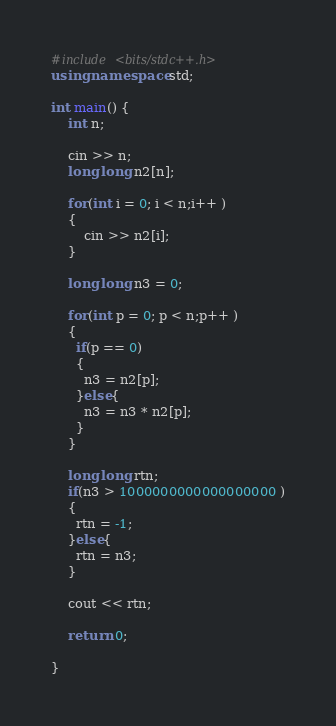<code> <loc_0><loc_0><loc_500><loc_500><_C++_>#include <bits/stdc++.h>
using namespace std;
 
int main() {
    int n;
    
    cin >> n;
    long long n2[n]; 
    
    for(int i = 0; i < n;i++ )
    {
    	cin >> n2[i];
    }
  
    long long n3 = 0;
  
    for(int p = 0; p < n;p++ )
    {
      if(p == 0)
      {
        n3 = n2[p];
      }else{
    	n3 = n3 * n2[p];
      }
    }
 
    long long rtn;
    if(n3 > 1000000000000000000 )
    {
      rtn = -1;
    }else{
      rtn = n3;
    }
  
    cout << rtn;

    return 0;

}</code> 